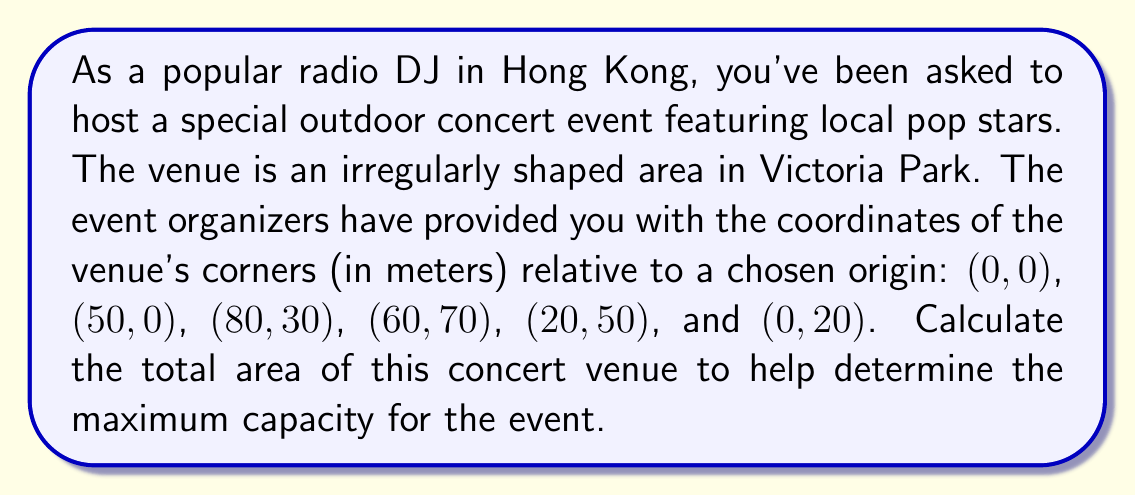Solve this math problem. To calculate the area of this irregular polygon, we can use the Shoelace formula (also known as the surveyor's formula). This method involves calculating the determinants of adjacent coordinate pairs and summing them up.

The formula for the area A of a polygon with n vertices $(x_1, y_1), (x_2, y_2), ..., (x_n, y_n)$ is:

$$A = \frac{1}{2}|(x_1y_2 + x_2y_3 + ... + x_ny_1) - (y_1x_2 + y_2x_3 + ... + y_nx_1)|$$

Let's apply this to our coordinates:

1) First, let's list our coordinates in order:
   $(0, 0), (50, 0), (80, 30), (60, 70), (20, 50), (0, 20)$

2) Now, let's calculate the first part of the formula:
   $$(0 \cdot 0) + (50 \cdot 30) + (80 \cdot 70) + (60 \cdot 50) + (20 \cdot 20) + (0 \cdot 0) = 1500 + 5600 + 3000 + 400 = 10500$$

3) Next, let's calculate the second part:
   $$(0 \cdot 50) + (0 \cdot 80) + (30 \cdot 60) + (70 \cdot 20) + (50 \cdot 0) + (20 \cdot 0) = 1800 + 1400 = 3200$$

4) Now, we subtract the second part from the first:
   $$10500 - 3200 = 7300$$

5) Finally, we divide by 2 to get the area:
   $$A = \frac{7300}{2} = 3650$$

Therefore, the area of the concert venue is 3650 square meters.

[asy]
unitsize(1cm);
draw((0,0)--(5,0)--(8,3)--(6,7)--(2,5)--(0,2)--cycle);
dot((0,0)); dot((5,0)); dot((8,3)); dot((6,7)); dot((2,5)); dot((0,2));
label("(0,0)", (0,0), SW);
label("(50,0)", (5,0), S);
label("(80,30)", (8,3), E);
label("(60,70)", (6,7), N);
label("(20,50)", (2,5), W);
label("(0,20)", (0,2), W);
[/asy]
Answer: The area of the irregularly shaped concert venue is 3650 square meters. 